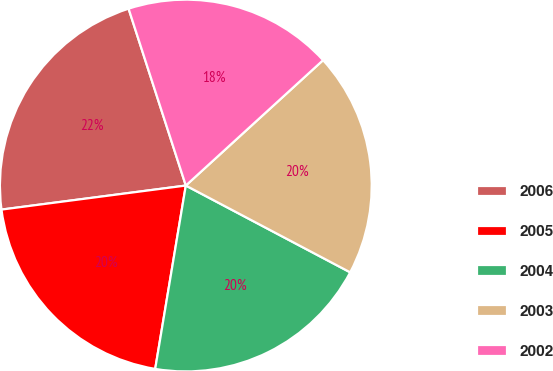<chart> <loc_0><loc_0><loc_500><loc_500><pie_chart><fcel>2006<fcel>2005<fcel>2004<fcel>2003<fcel>2002<nl><fcel>22.08%<fcel>20.3%<fcel>19.9%<fcel>19.51%<fcel>18.2%<nl></chart> 